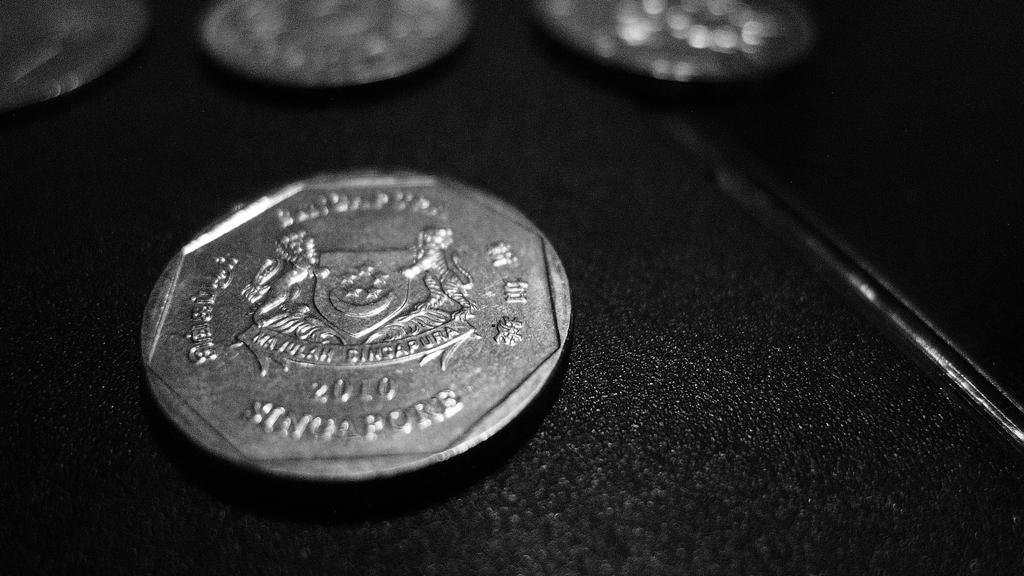What is the color of the surface in the image? The surface in the image is black. What objects are on the black surface? There are coins on the black surface. How are the coins on the black surface? The coins are carved. What type of shoes can be seen in the image? There are no shoes present in the image. What idea is being conveyed by the coins in the image? The image does not convey any specific idea; it simply shows coins on a black surface. 